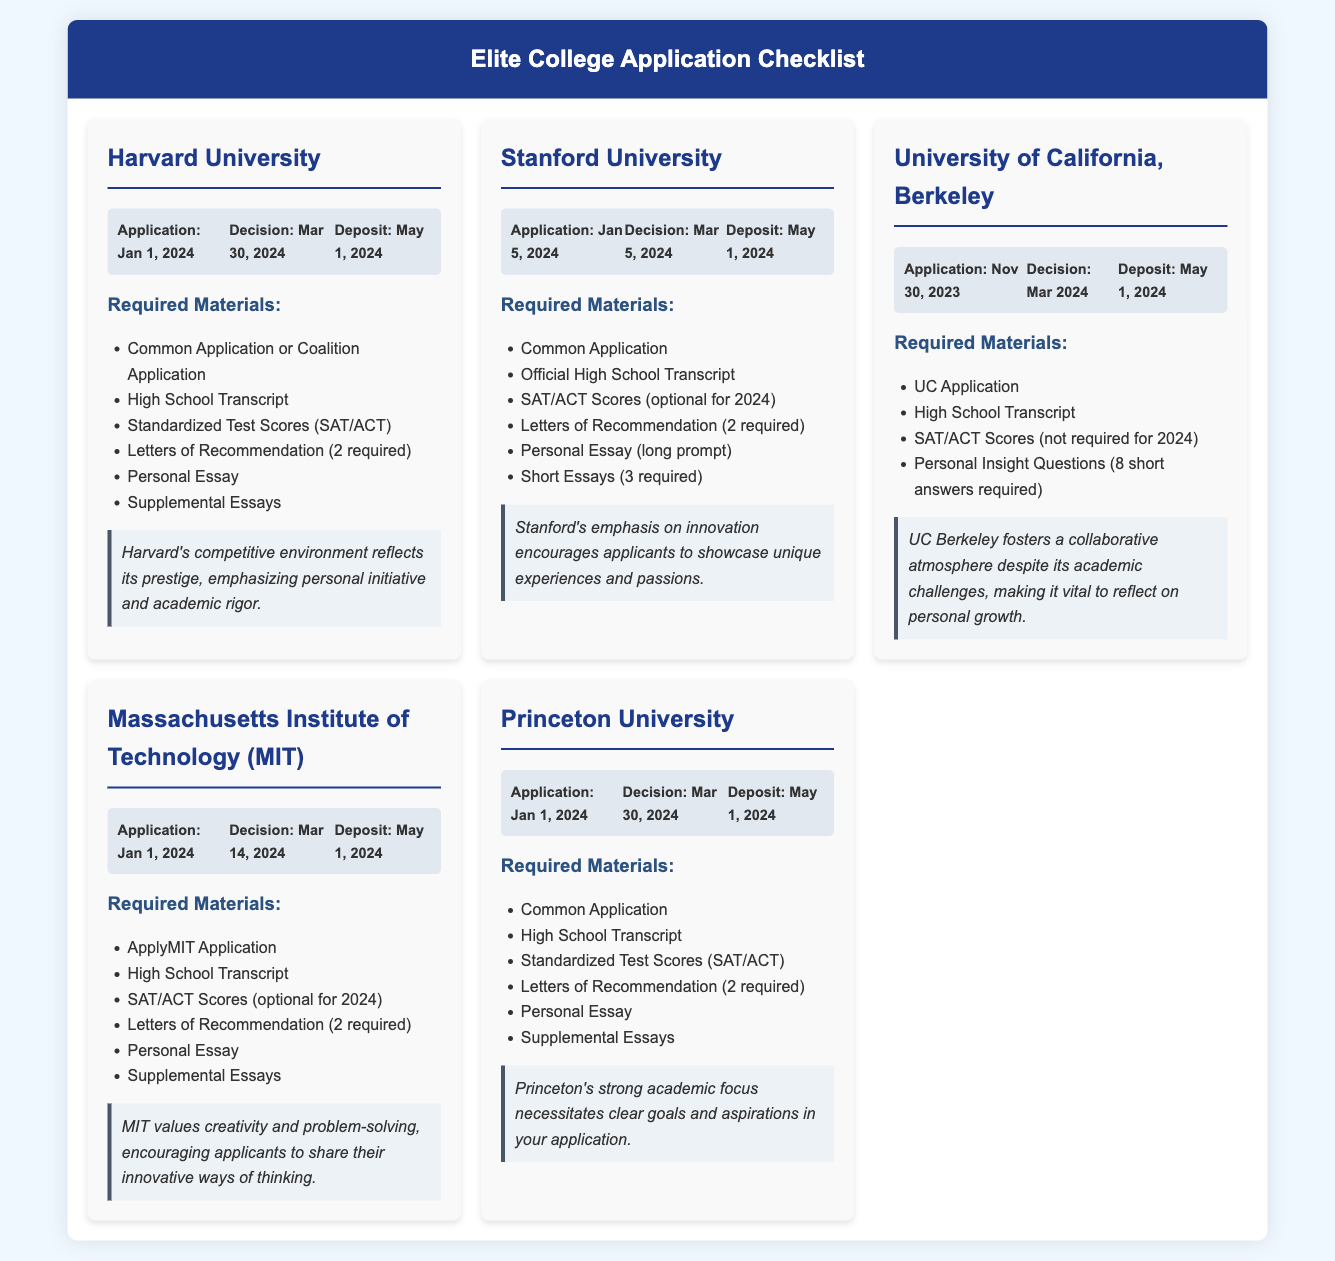What is the application deadline for Harvard University? The application deadline is stated in the document as Jan 1, 2024.
Answer: Jan 1, 2024 What are two required materials for Stanford University? The document lists the required materials for Stanford University, which include the Common Application and Official High School Transcript.
Answer: Common Application, Official High School Transcript When is the deposit due for all the colleges listed? The deposit due date is consistent across all listed colleges, mentioned as May 1, 2024.
Answer: May 1, 2024 Which college emphasizes personal initiative and academic rigor? The reflection section for Harvard states that it emphasizes personal initiative and academic rigor.
Answer: Harvard University What is a unique characteristic of MIT that applicants should highlight? The reflection for MIT mentions that applicants should share their innovative ways of thinking.
Answer: Innovative ways of thinking How many letters of recommendation are required for Princeton University? The document indicates that 2 letters of recommendation are required for Princeton University.
Answer: 2 What type of application is required for UC Berkeley? The required application type for UC Berkeley is noted as UC Application.
Answer: UC Application What is the decision date for Stanford University? The decision date for Stanford University is specified as Mar 5, 2024.
Answer: Mar 5, 2024 What do applicants need to reflect on for UC Berkeley? The reflection states that applicants should reflect on personal growth.
Answer: Personal growth 